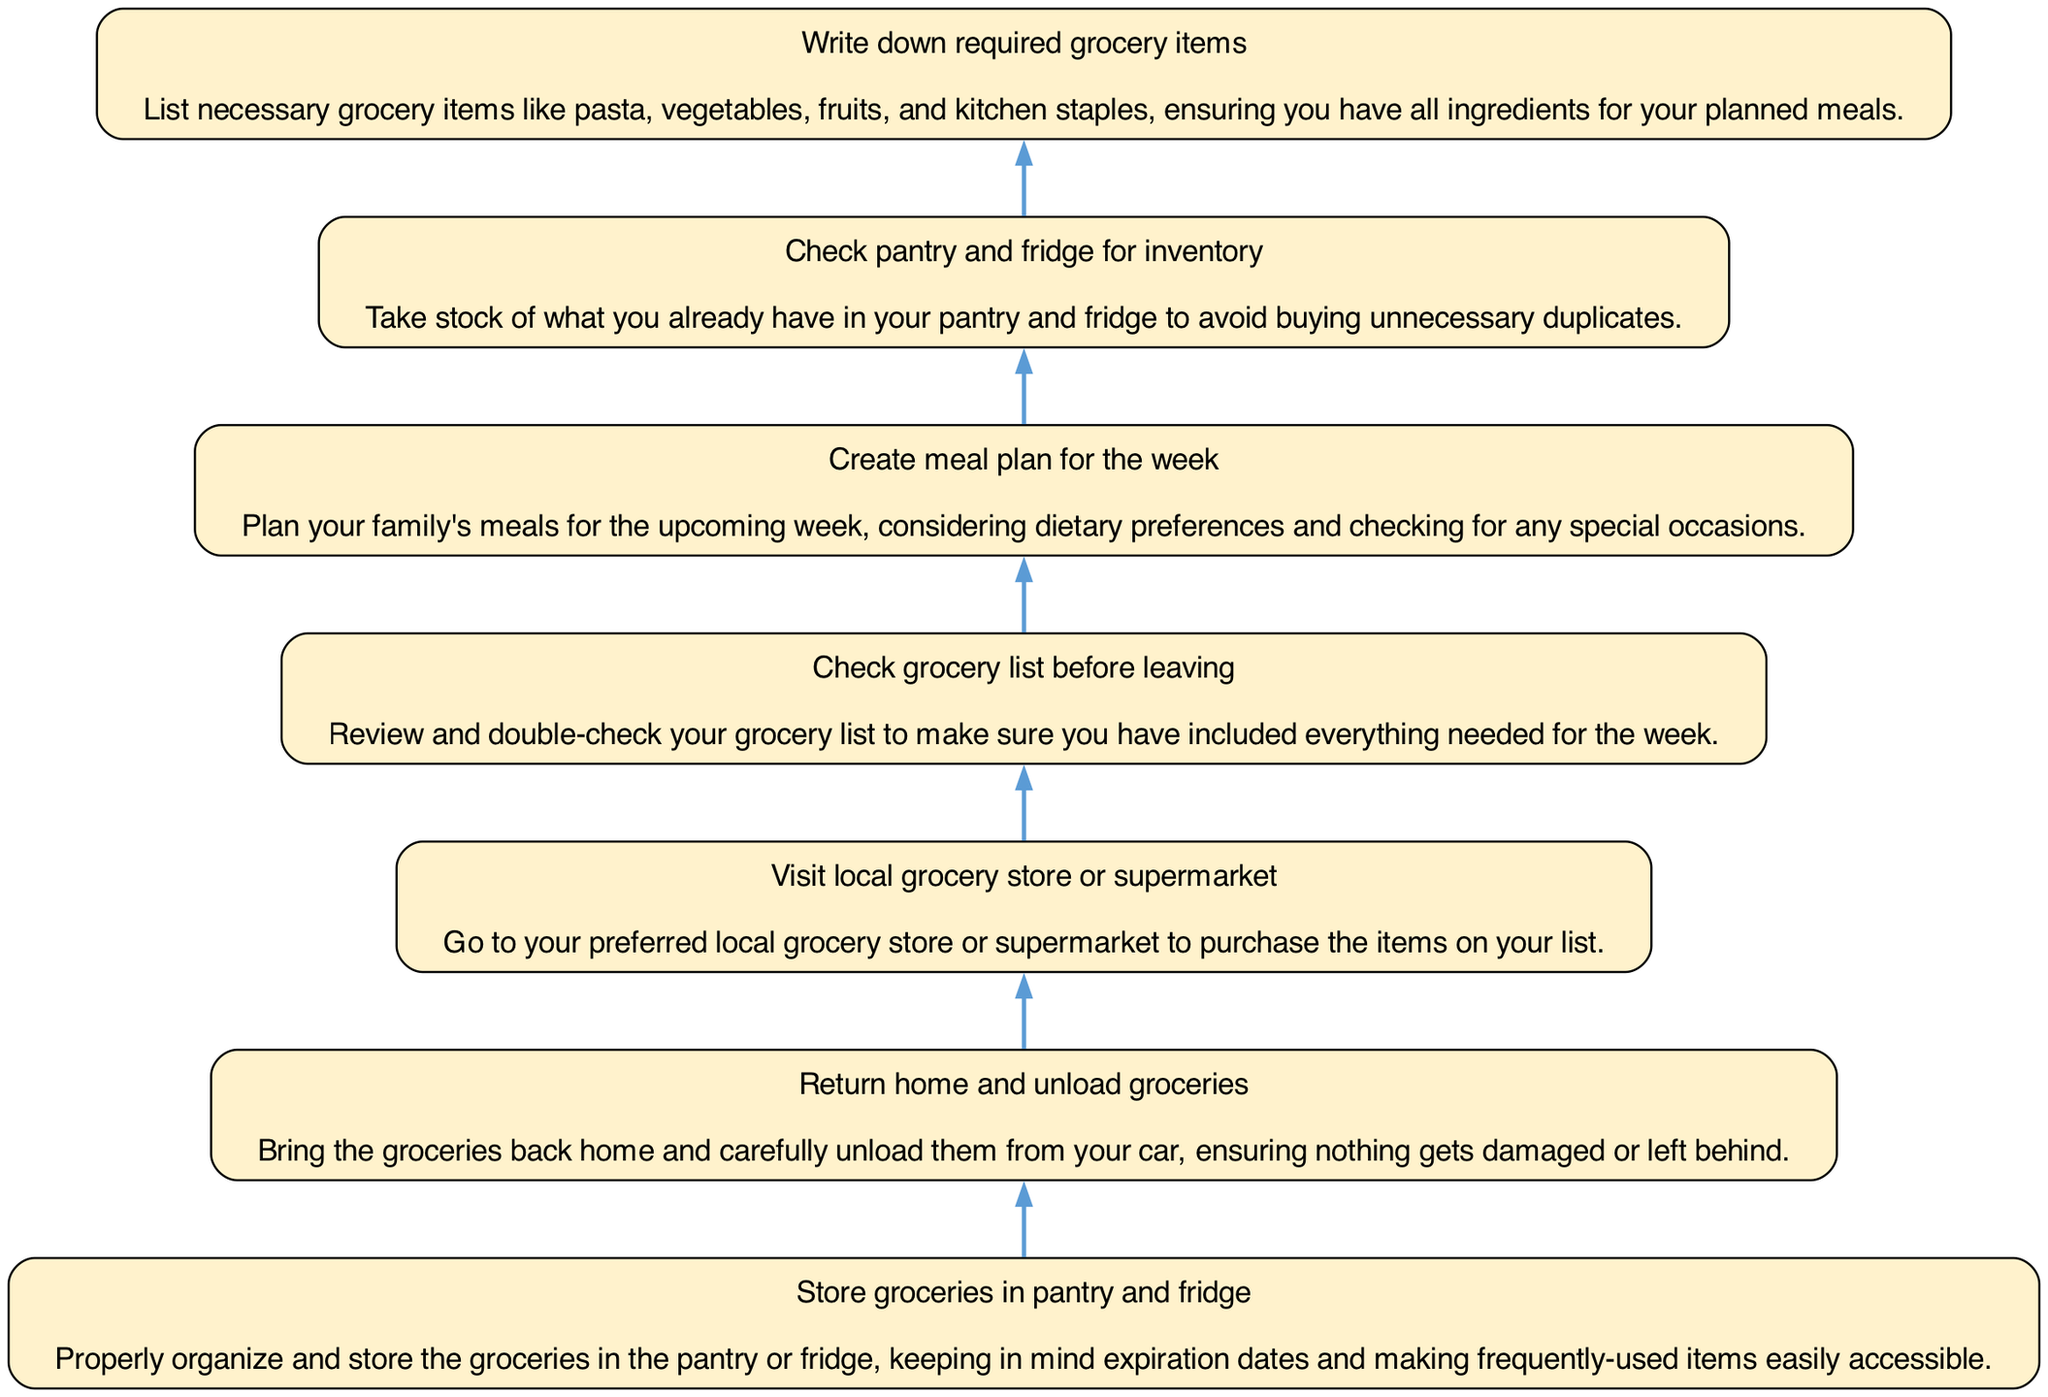What is the first step in the diagram? The diagram indicates that the first step, when flowing from bottom to top, is to "Write down required grocery items." This represents the starting point before any grocery shopping occurs.
Answer: Write down required grocery items How many total steps are in the diagram? By counting all unique process nodes from bottom to top, there are seven distinct steps depicted for organizing grocery shopping.
Answer: 7 What is the last step before storing groceries? The step right before "Store groceries in pantry and fridge" is "Return home and unload groceries." This represents the transition from shopping to organizing at home.
Answer: Return home and unload groceries What should you do after visiting the grocery store? After visiting the grocery store, the next step is to "Return home and unload groceries." This demonstrates the sequential nature of the process following shopping.
Answer: Return home and unload groceries Which step requires checking the pantry and fridge? The step that involves checking the pantry and fridge is "Check pantry and fridge for inventory." This is crucial to ensure you do not purchase unnecessary items.
Answer: Check pantry and fridge for inventory What is the purpose of creating a meal plan? The "Create meal plan for the week" step allows for efficient grocery shopping by ensuring that all necessary ingredients for planned meals are taken into account.
Answer: Plan meals for the week Which action must be completed before writing down grocery items? Before writing down required grocery items, the step "Check pantry and fridge for inventory" must be completed. This step ensures that only necessary items are included in the shopping list.
Answer: Check pantry and fridge for inventory 